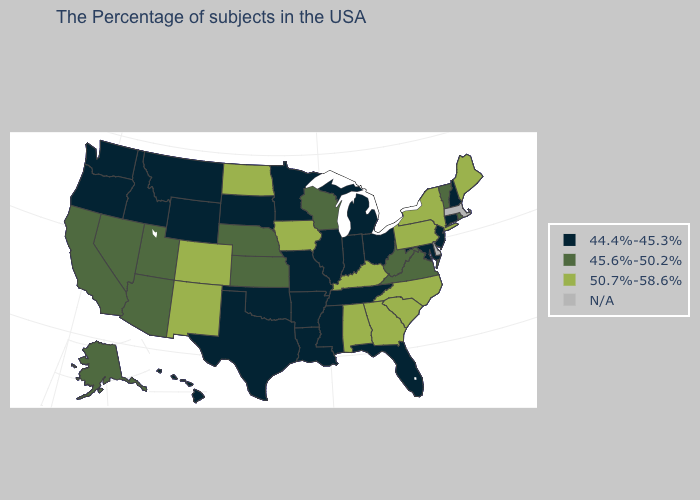What is the value of South Carolina?
Short answer required. 50.7%-58.6%. Which states have the highest value in the USA?
Concise answer only. Maine, New York, Pennsylvania, North Carolina, South Carolina, Georgia, Kentucky, Alabama, Iowa, North Dakota, Colorado, New Mexico. Which states have the lowest value in the MidWest?
Give a very brief answer. Ohio, Michigan, Indiana, Illinois, Missouri, Minnesota, South Dakota. Does New Jersey have the lowest value in the Northeast?
Write a very short answer. Yes. Does Montana have the highest value in the USA?
Answer briefly. No. Among the states that border Minnesota , which have the highest value?
Keep it brief. Iowa, North Dakota. Which states have the highest value in the USA?
Concise answer only. Maine, New York, Pennsylvania, North Carolina, South Carolina, Georgia, Kentucky, Alabama, Iowa, North Dakota, Colorado, New Mexico. Which states have the lowest value in the Northeast?
Answer briefly. New Hampshire, Connecticut, New Jersey. What is the value of Montana?
Write a very short answer. 44.4%-45.3%. What is the lowest value in the South?
Concise answer only. 44.4%-45.3%. What is the lowest value in the West?
Short answer required. 44.4%-45.3%. Name the states that have a value in the range N/A?
Write a very short answer. Massachusetts, Delaware. Among the states that border Kansas , which have the highest value?
Concise answer only. Colorado. 